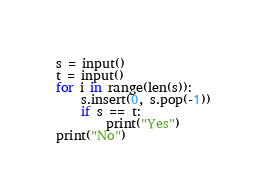Convert code to text. <code><loc_0><loc_0><loc_500><loc_500><_Python_>s = input()
t = input()
for i in range(len(s)):
    s.insert(0, s.pop(-1))
    if s == t:
        print("Yes")
print("No")</code> 